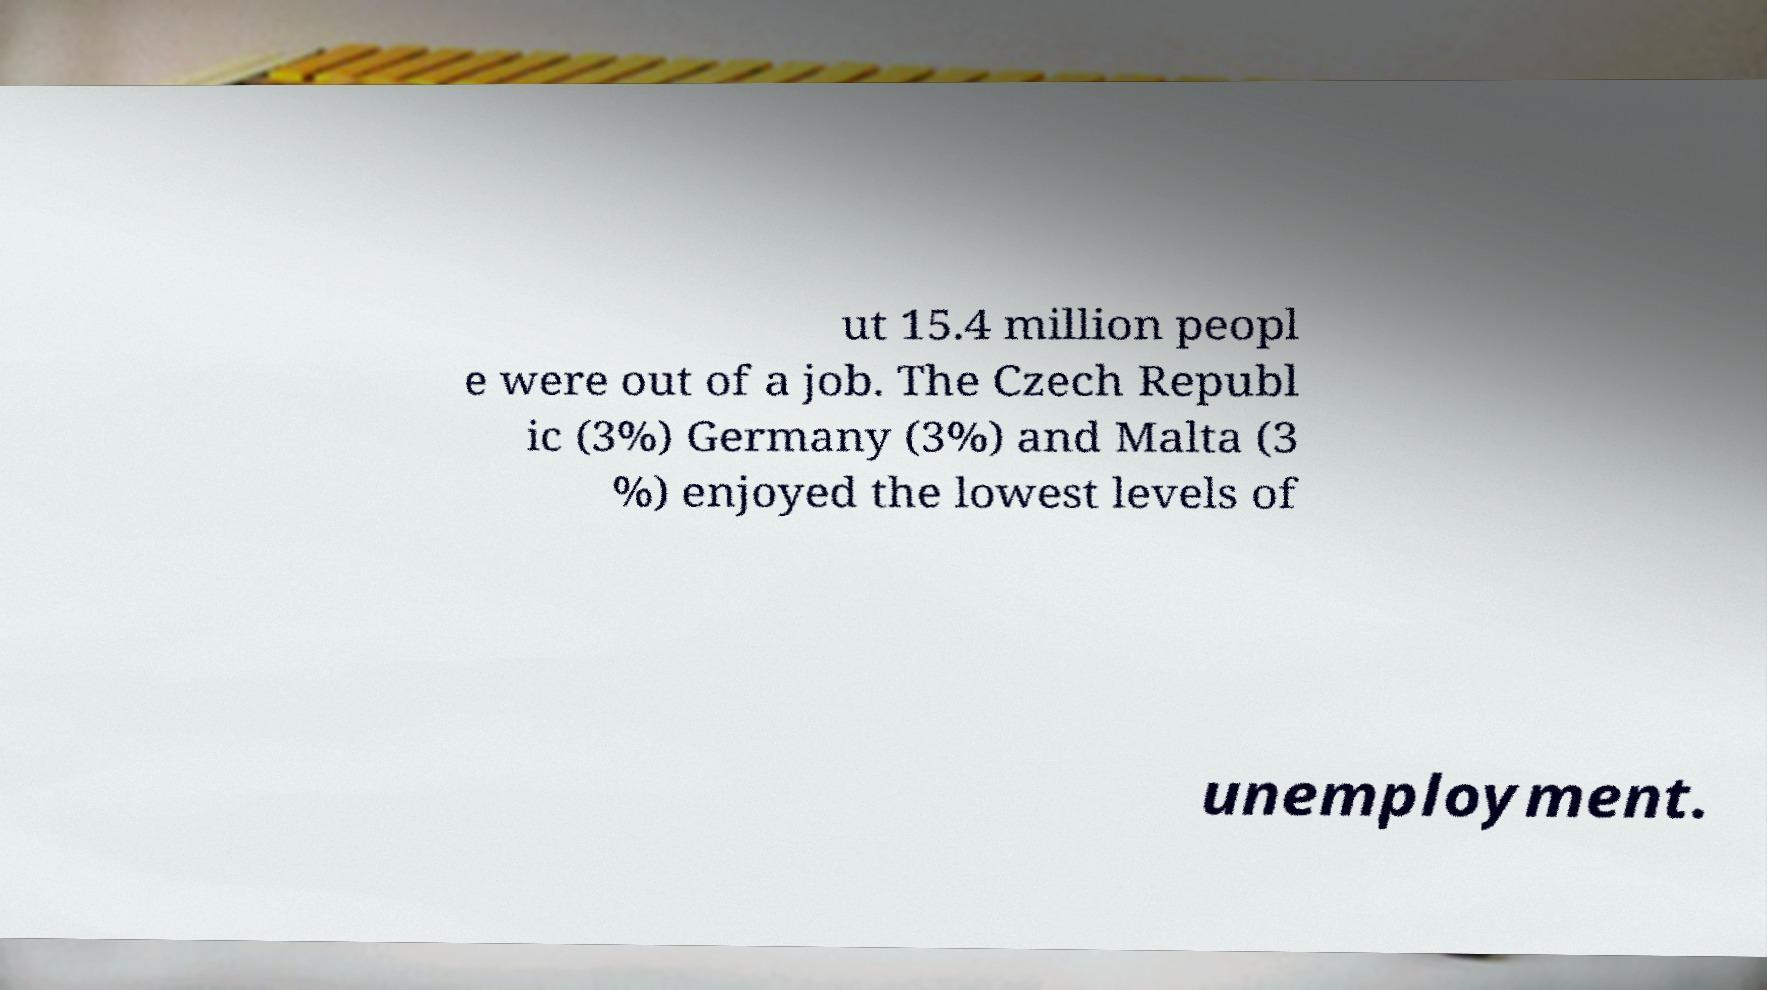Can you read and provide the text displayed in the image?This photo seems to have some interesting text. Can you extract and type it out for me? ut 15.4 million peopl e were out of a job. The Czech Republ ic (3%) Germany (3%) and Malta (3 %) enjoyed the lowest levels of unemployment. 